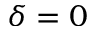<formula> <loc_0><loc_0><loc_500><loc_500>\delta = 0</formula> 